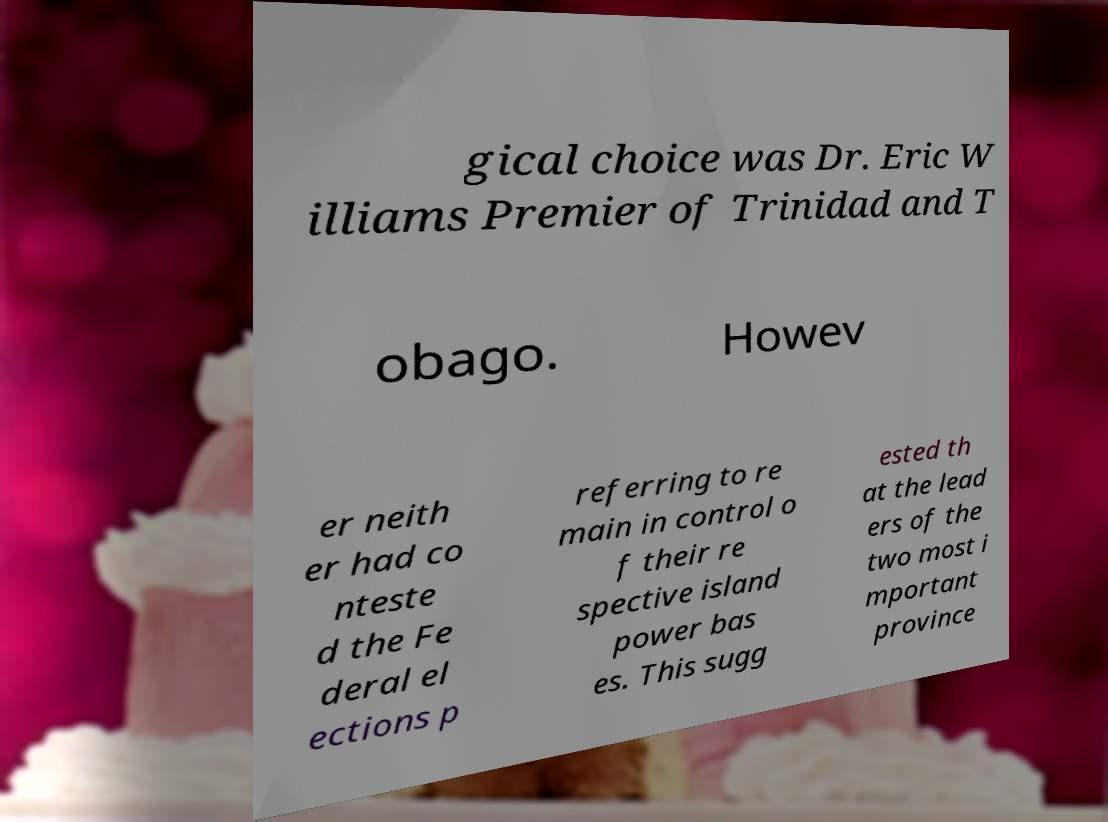What messages or text are displayed in this image? I need them in a readable, typed format. gical choice was Dr. Eric W illiams Premier of Trinidad and T obago. Howev er neith er had co nteste d the Fe deral el ections p referring to re main in control o f their re spective island power bas es. This sugg ested th at the lead ers of the two most i mportant province 